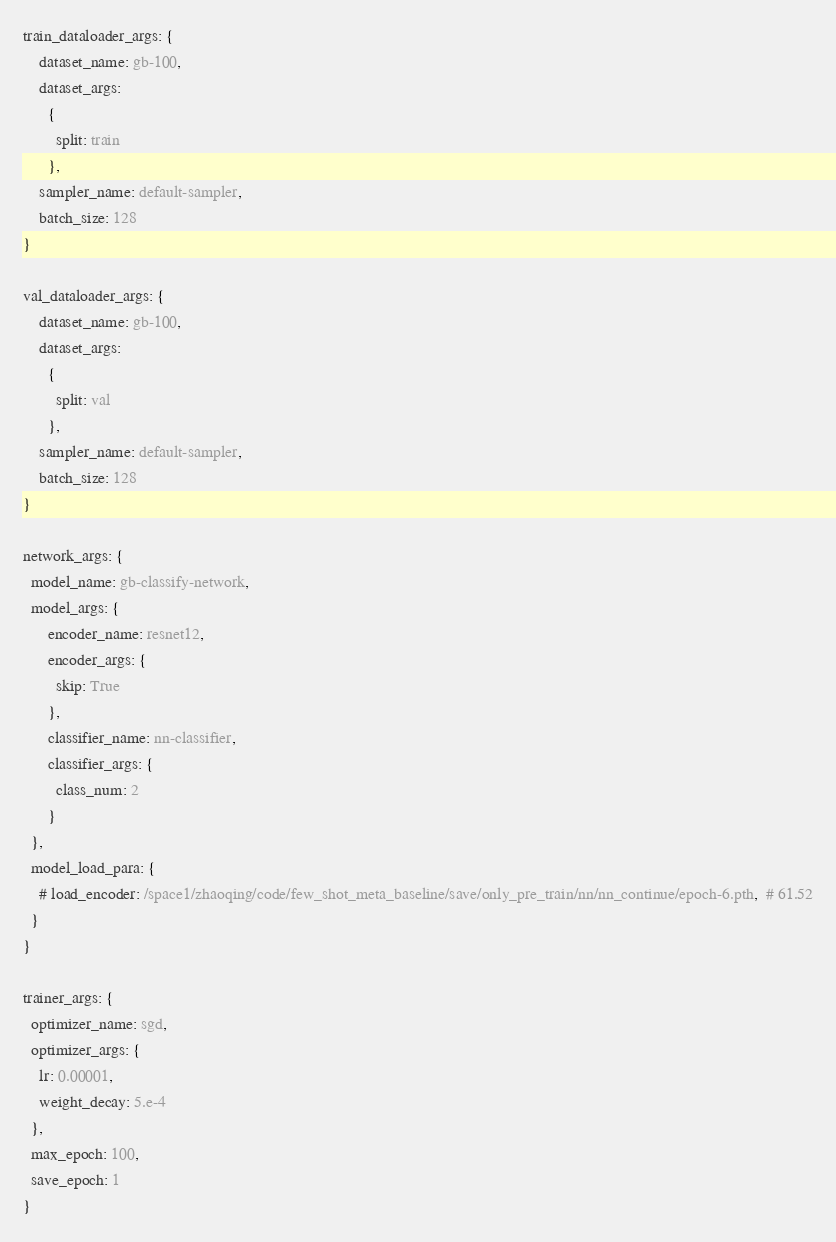<code> <loc_0><loc_0><loc_500><loc_500><_YAML_>train_dataloader_args: {
    dataset_name: gb-100,
    dataset_args:
      {
        split: train
      },
    sampler_name: default-sampler,
    batch_size: 128
}

val_dataloader_args: {
    dataset_name: gb-100,
    dataset_args:
      {
        split: val
      },
    sampler_name: default-sampler,
    batch_size: 128
}

network_args: {
  model_name: gb-classify-network,
  model_args: {
      encoder_name: resnet12,
      encoder_args: {
        skip: True
      },
      classifier_name: nn-classifier,
      classifier_args: {
        class_num: 2
      }
  },
  model_load_para: {
    # load_encoder: /space1/zhaoqing/code/few_shot_meta_baseline/save/only_pre_train/nn/nn_continue/epoch-6.pth,  # 61.52
  }
}

trainer_args: {
  optimizer_name: sgd,
  optimizer_args: {
    lr: 0.00001,
    weight_decay: 5.e-4
  },
  max_epoch: 100,
  save_epoch: 1
}

</code> 